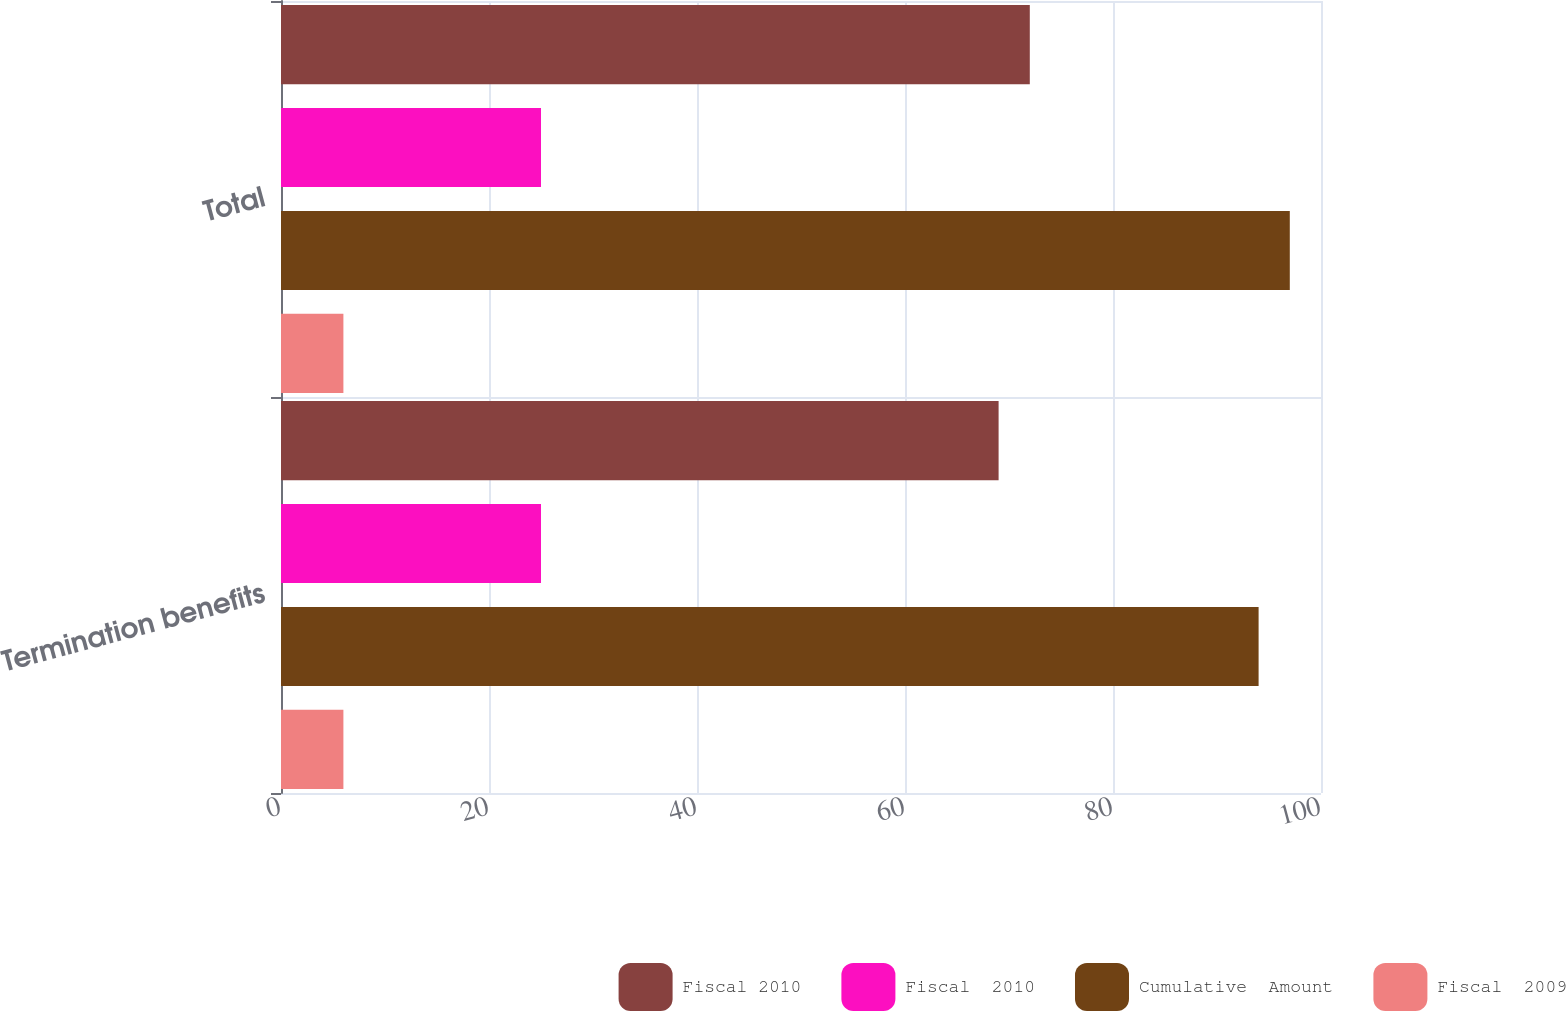<chart> <loc_0><loc_0><loc_500><loc_500><stacked_bar_chart><ecel><fcel>Termination benefits<fcel>Total<nl><fcel>Fiscal 2010<fcel>69<fcel>72<nl><fcel>Fiscal  2010<fcel>25<fcel>25<nl><fcel>Cumulative  Amount<fcel>94<fcel>97<nl><fcel>Fiscal  2009<fcel>6<fcel>6<nl></chart> 